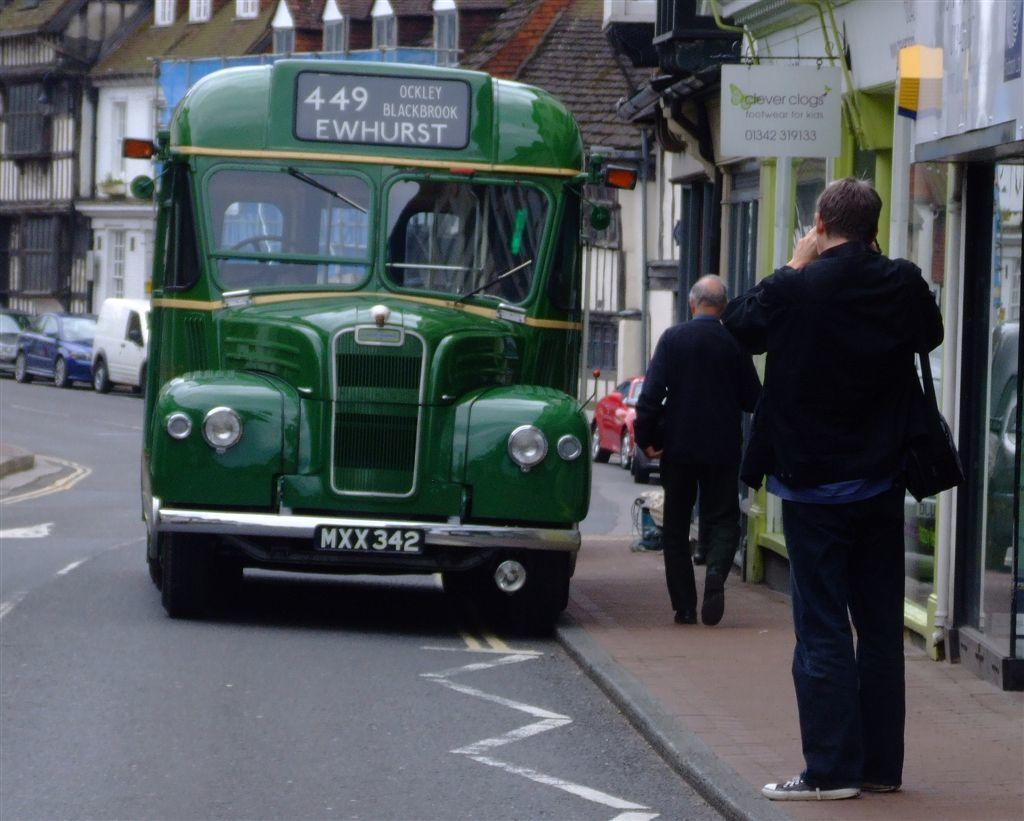<image>
Write a terse but informative summary of the picture. a green bus on the road number 449 to EWHURST 